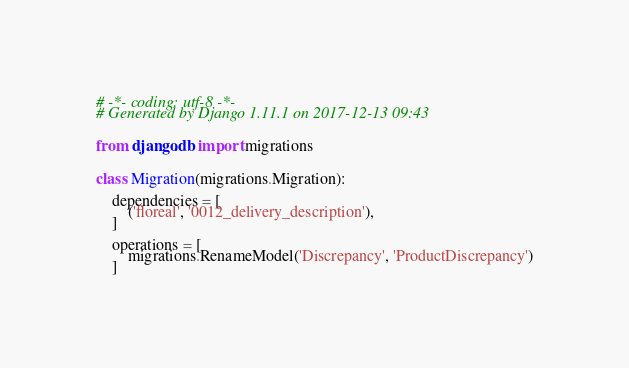Convert code to text. <code><loc_0><loc_0><loc_500><loc_500><_Python_># -*- coding: utf-8 -*-
# Generated by Django 1.11.1 on 2017-12-13 09:43


from django.db import migrations


class Migration(migrations.Migration):

    dependencies = [
        ('floreal', '0012_delivery_description'),
    ]

    operations = [
        migrations.RenameModel('Discrepancy', 'ProductDiscrepancy')
    ]
</code> 